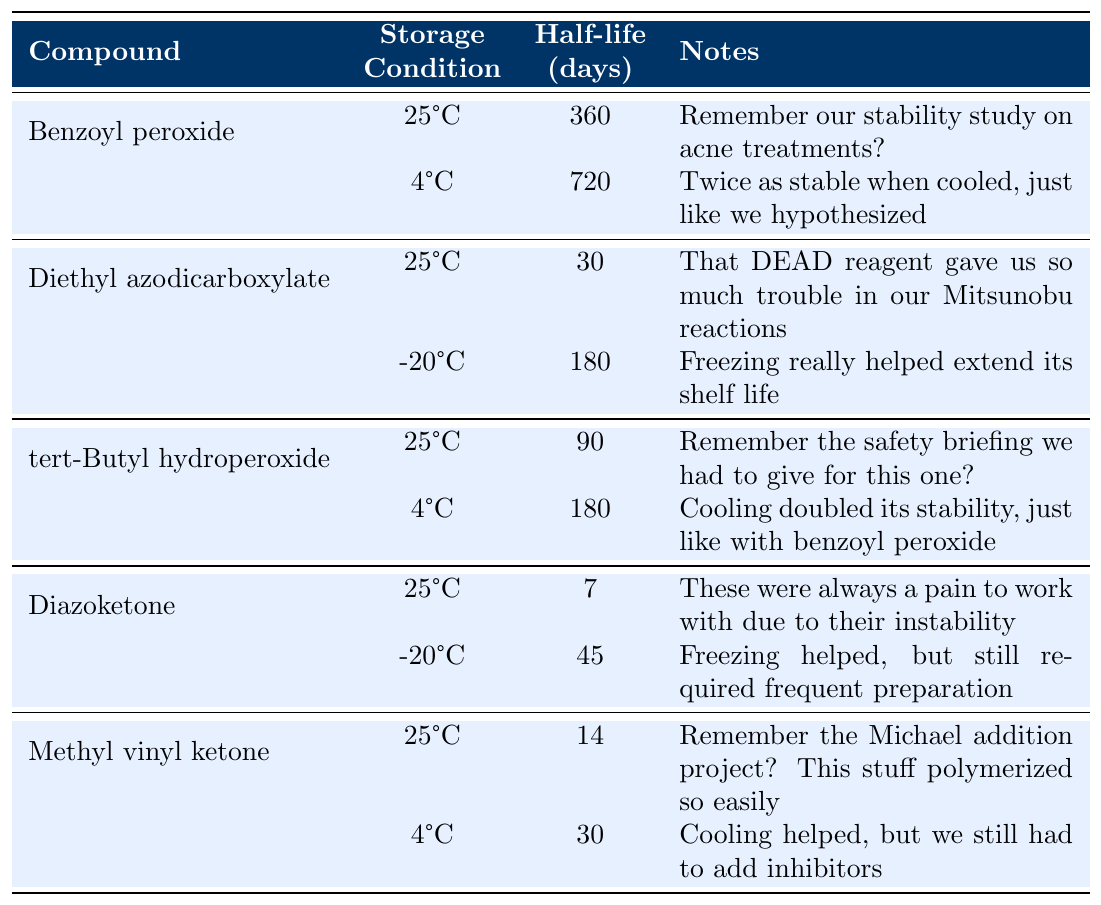What is the half-life of Benzoyl peroxide at room temperature? The table indicates that the half-life of Benzoyl peroxide at room temperature (25°C) is 360 days.
Answer: 360 days How much longer is the half-life of Benzoyl peroxide when refrigerated compared to at room temperature? The half-life of Benzoyl peroxide at refrigerated conditions is 720 days. The difference is calculated as 720 days - 360 days = 360 days.
Answer: 360 days Is the half-life of Diethyl azodicarboxylate longer when stored frozen or at room temperature? The half-life at room temperature is 30 days, and when frozen, it is 180 days. Therefore, the half-life is longer when frozen.
Answer: Yes What is the half-life of Diazoketone at room temperature? According to the table, the half-life of Diazoketone at room temperature (25°C) is listed as 7 days.
Answer: 7 days Which compound showed the greatest increase in half-life when stored at lower temperatures? Benzoyl peroxide increases from 360 days at 25°C to 720 days at 4°C, while other compounds also increase but not as much. The increase paralleled with Benzoyl peroxide's half-life of 360 days, making it the greatest.
Answer: Benzoyl peroxide What is the average half-life of tert-Butyl hydroperoxide at both temperatures? At room temperature, the half-life is 90 days, and at 4°C, it is 180 days. The average is calculated as (90 + 180)/2 = 135 days.
Answer: 135 days By how many days does the half-life of Methyl vinyl ketone increase when refrigerated? The half-life of Methyl vinyl ketone at room temperature is 14 days, and it increases to 30 days when refrigerated. The increase is 30 days - 14 days = 16 days.
Answer: 16 days Which compound has the shortest half-life at room temperature? The table states that Diazoketone has the shortest half-life at room temperature with just 7 days.
Answer: Diazoketone If a storage condition increases the half-life significantly, which condition had that effect for Diethyl azodicarboxylate? The table shows that storing Diethyl azodicarboxylate at -20°C (frozen) increases its half-life from 30 days at room temperature to 180 days.
Answer: -20°C (frozen) What is the combined half-life of Diethyl azodicarboxylate in both storage conditions? The combined half-life is calculated as 30 days (room temperature) + 180 days (frozen) = 210 days.
Answer: 210 days 